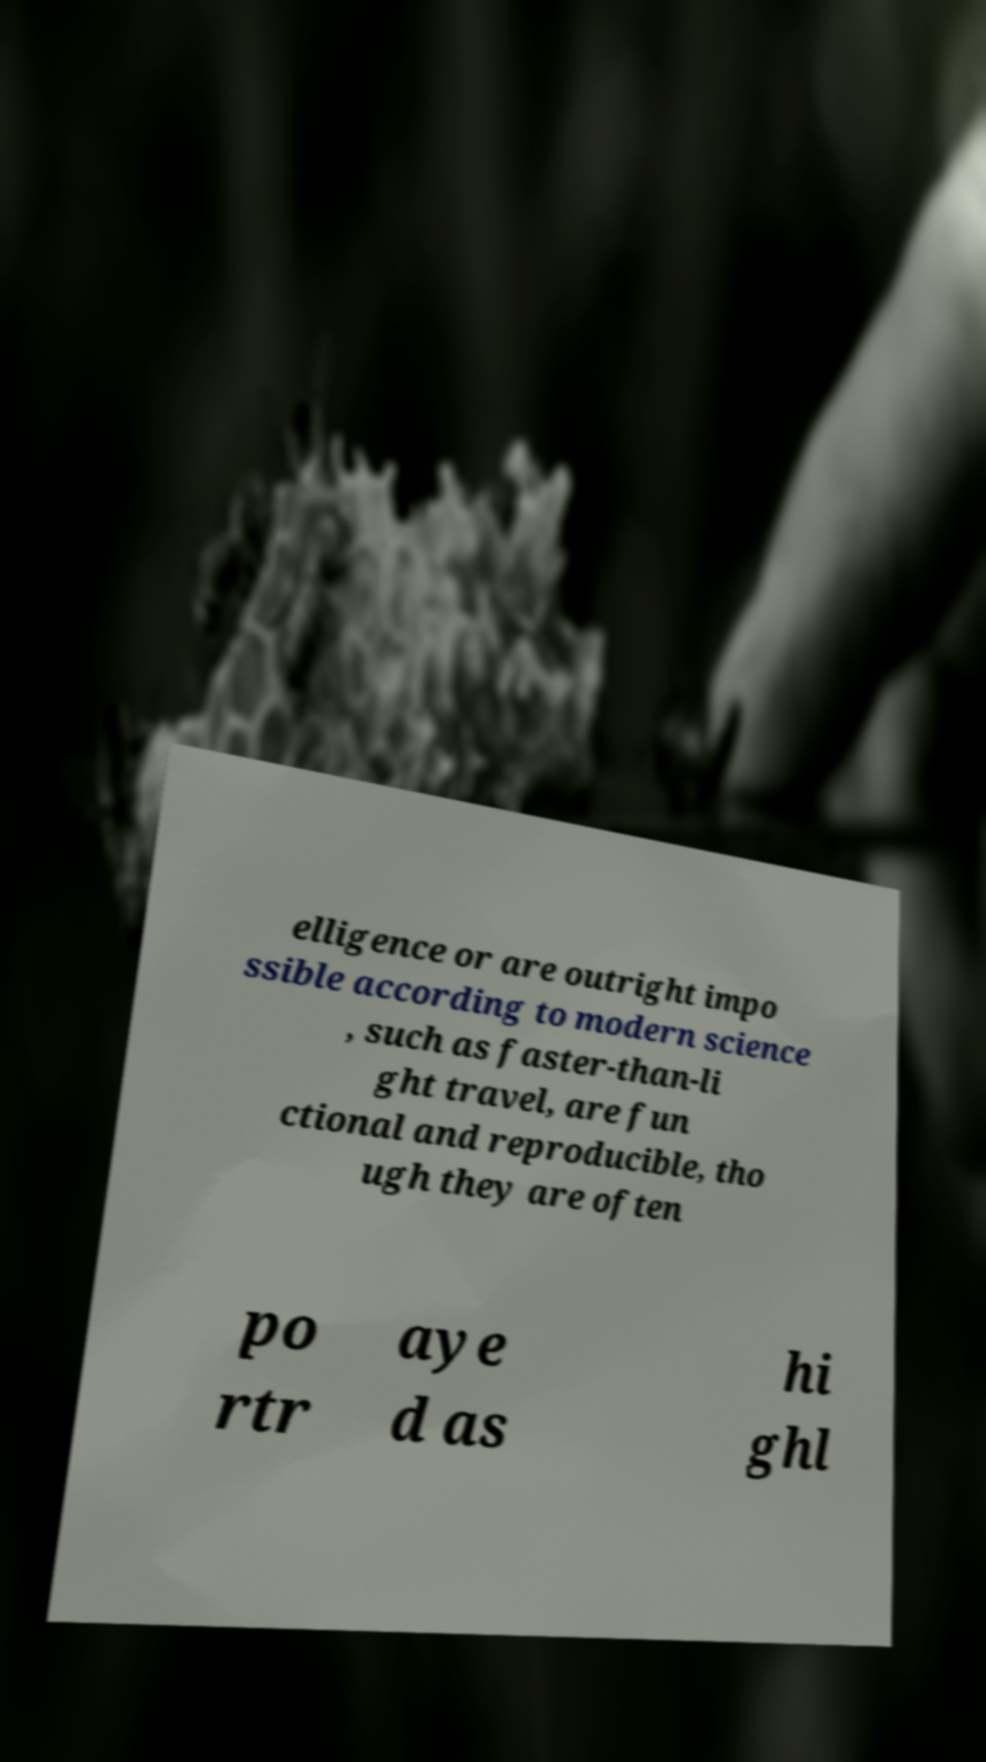What messages or text are displayed in this image? I need them in a readable, typed format. elligence or are outright impo ssible according to modern science , such as faster-than-li ght travel, are fun ctional and reproducible, tho ugh they are often po rtr aye d as hi ghl 